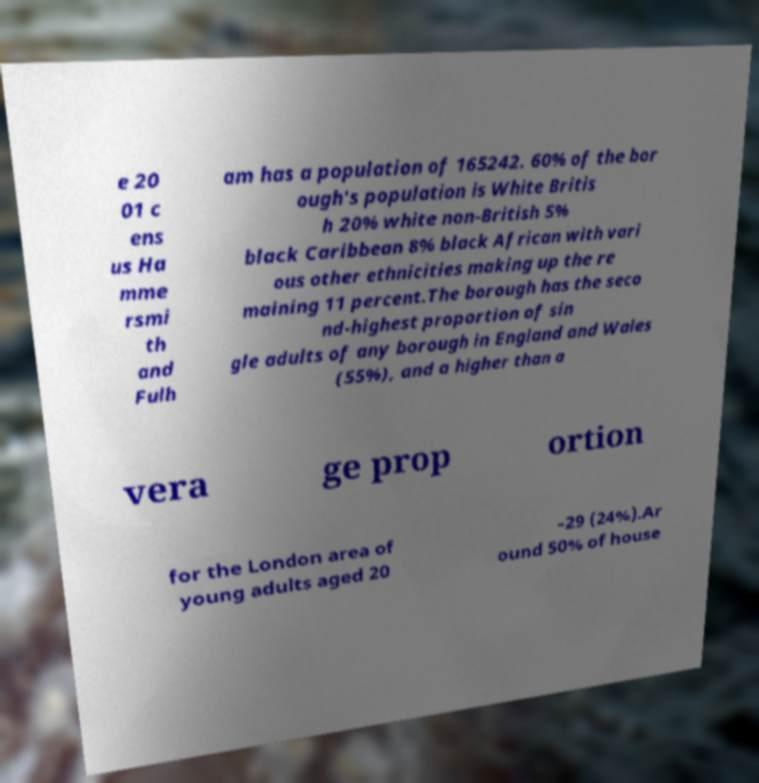Please read and relay the text visible in this image. What does it say? e 20 01 c ens us Ha mme rsmi th and Fulh am has a population of 165242. 60% of the bor ough's population is White Britis h 20% white non-British 5% black Caribbean 8% black African with vari ous other ethnicities making up the re maining 11 percent.The borough has the seco nd-highest proportion of sin gle adults of any borough in England and Wales (55%), and a higher than a vera ge prop ortion for the London area of young adults aged 20 –29 (24%).Ar ound 50% of house 